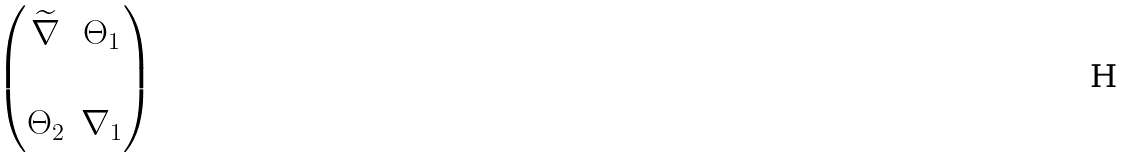<formula> <loc_0><loc_0><loc_500><loc_500>\begin{pmatrix} \widetilde { \nabla } & \Theta _ { 1 } \\ & \\ \Theta _ { 2 } & \nabla _ { 1 } \end{pmatrix}</formula> 